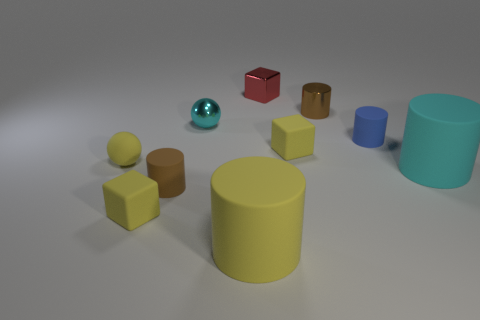Subtract all blue cylinders. How many cylinders are left? 4 Subtract all shiny cylinders. How many cylinders are left? 4 Subtract all red cylinders. Subtract all brown balls. How many cylinders are left? 5 Subtract all cubes. How many objects are left? 7 Add 1 yellow balls. How many yellow balls exist? 2 Subtract 0 green cylinders. How many objects are left? 10 Subtract all red metal blocks. Subtract all rubber cylinders. How many objects are left? 5 Add 4 yellow matte cylinders. How many yellow matte cylinders are left? 5 